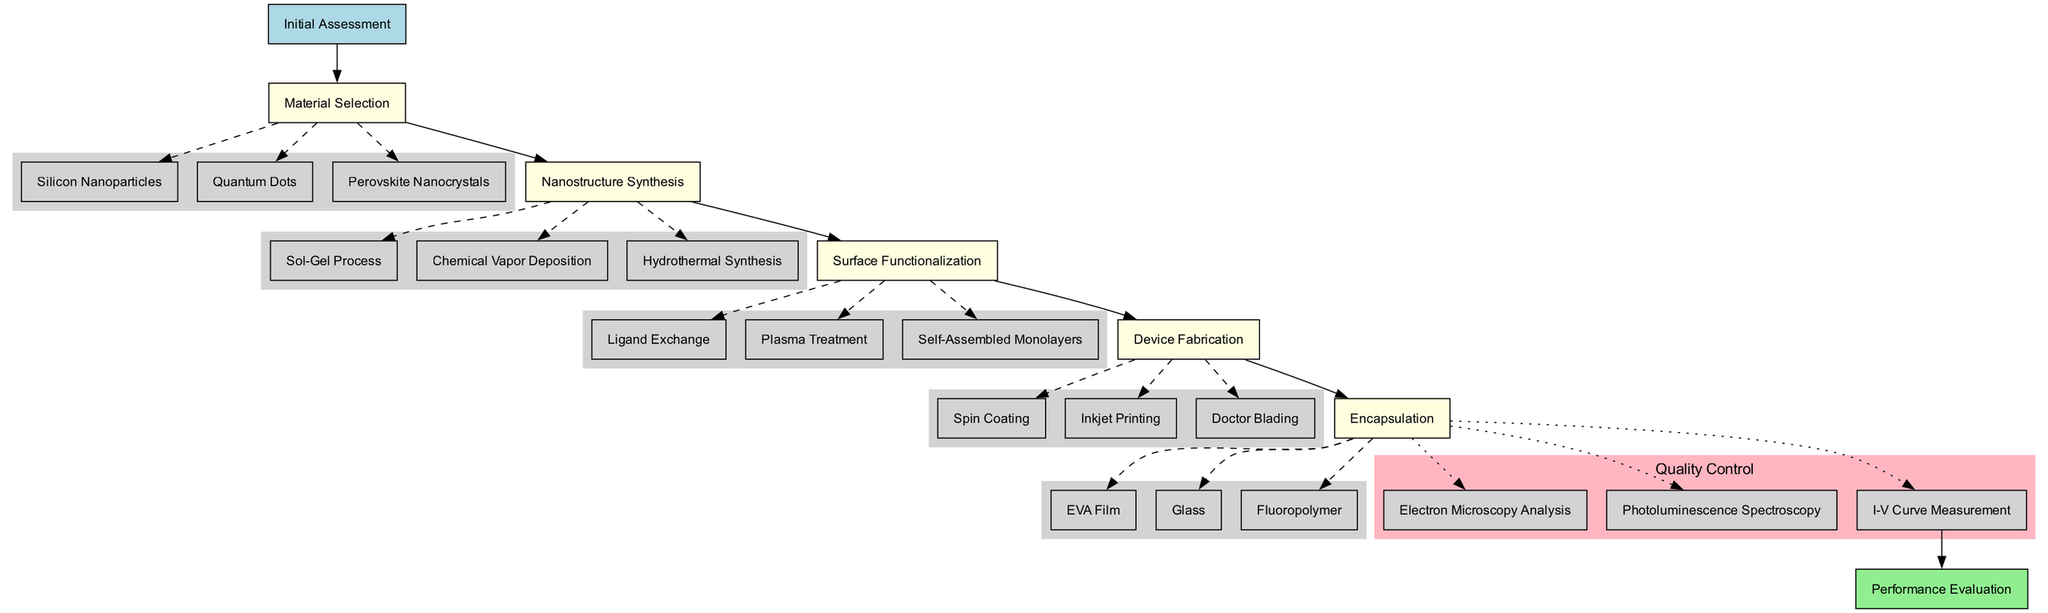What is the starting point of the clinical pathway? The diagram explicitly states "Initial Assessment" as the starting point, indicating the beginning of the process.
Answer: Initial Assessment How many options are available for the Material Selection step? The diagram lists three options under the Material Selection step: Silicon Nanoparticles, Quantum Dots, and Perovskite Nanocrystals, making it clear there are three options.
Answer: 3 What are the processes listed under the Device Fabrication step? By examining the Device Fabrication step, the processes listed are: Spin Coating, Inkjet Printing, and Doctor Blading, therefore there are these three distinct processes.
Answer: Spin Coating, Inkjet Printing, Doctor Blading What is the endpoint of the clinical pathway? The diagram identifies "Performance Evaluation" as the endpoint, marking the conclusion of the clinical pathway process.
Answer: Performance Evaluation What techniques are listed under the Surface Functionalization step? The Surface Functionalization step specifies three techniques: Ligand Exchange, Plasma Treatment, and Self-Assembled Monolayers, which can be directly referenced in the diagram.
Answer: Ligand Exchange, Plasma Treatment, Self-Assembled Monolayers Which step in the clinical pathway follows Material Selection? According to the diagram, Nanostructure Synthesis directly follows the Material Selection step, representing the subsequent stage in the clinical process.
Answer: Nanostructure Synthesis How are the quality control measures connected to the last step in the pathway? The diagram shows that quality control measures, including Electron Microscopy Analysis, Photoluminescence Spectroscopy, and I-V Curve Measurement, are linked to the last step (Device Fabrication) with a dotted edge, denoting a quality assessment can occur thereafter.
Answer: With a dotted edge What is the order of steps from Initial Assessment to Performance Evaluation? The order can be traced in a sequential manner through the nodes: Initial Assessment → Material Selection → Nanostructure Synthesis → Surface Functionalization → Device Fabrication → Quality Control → Performance Evaluation.
Answer: Initial Assessment, Material Selection, Nanostructure Synthesis, Surface Functionalization, Device Fabrication, Quality Control, Performance Evaluation What type of analysis is included in the quality control section? The quality control section features various analysis types such as Electron Microscopy Analysis, Photoluminescence Spectroscopy, and I-V Curve Measurement, which specify the assessments made on the manufactured solar cells.
Answer: Electron Microscopy Analysis, Photoluminescence Spectroscopy, I-V Curve Measurement 